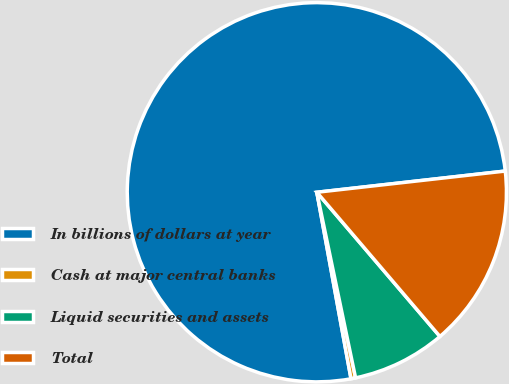<chart> <loc_0><loc_0><loc_500><loc_500><pie_chart><fcel>In billions of dollars at year<fcel>Cash at major central banks<fcel>Liquid securities and assets<fcel>Total<nl><fcel>76.1%<fcel>0.39%<fcel>7.97%<fcel>15.54%<nl></chart> 